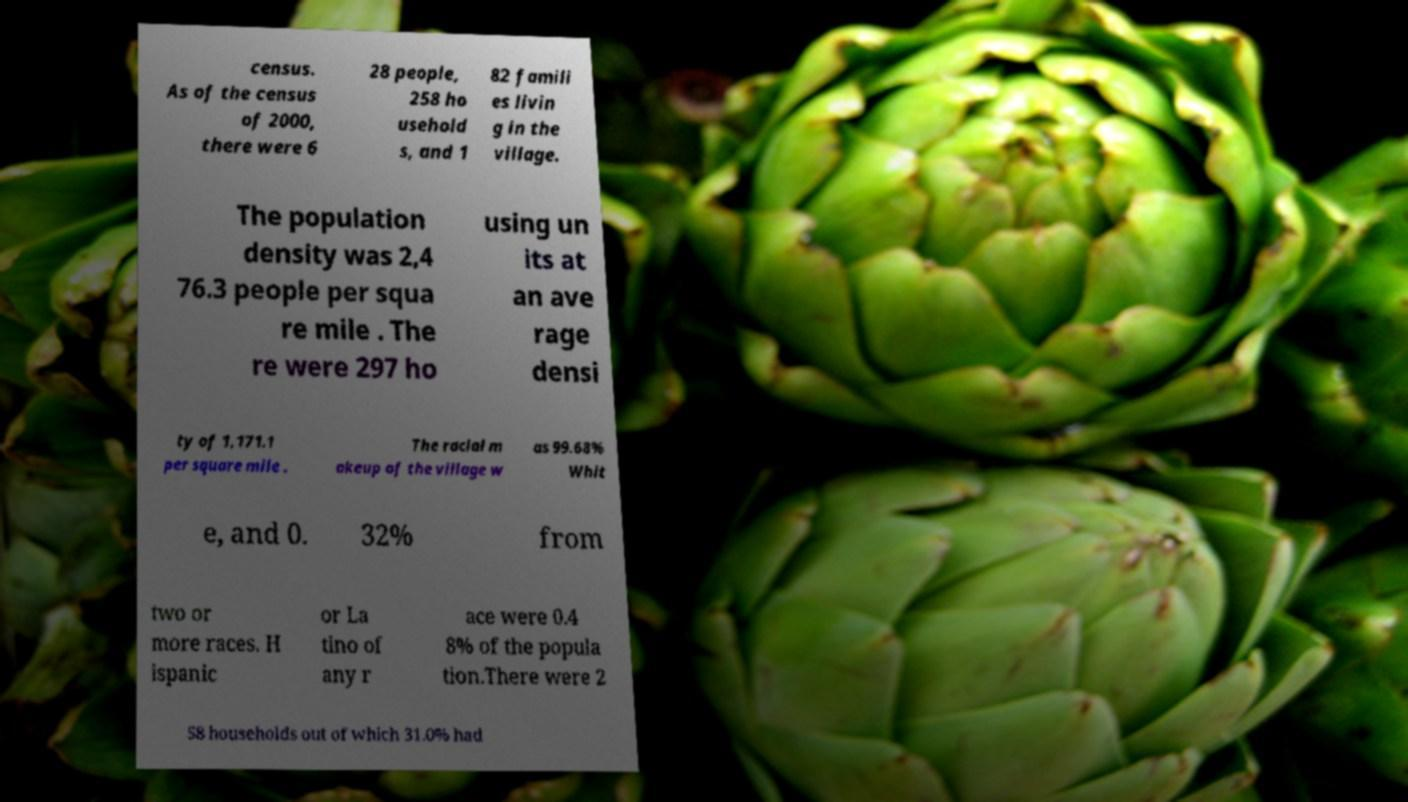Can you accurately transcribe the text from the provided image for me? census. As of the census of 2000, there were 6 28 people, 258 ho usehold s, and 1 82 famili es livin g in the village. The population density was 2,4 76.3 people per squa re mile . The re were 297 ho using un its at an ave rage densi ty of 1,171.1 per square mile . The racial m akeup of the village w as 99.68% Whit e, and 0. 32% from two or more races. H ispanic or La tino of any r ace were 0.4 8% of the popula tion.There were 2 58 households out of which 31.0% had 